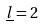Convert formula to latex. <formula><loc_0><loc_0><loc_500><loc_500>\underline { l } = 2</formula> 